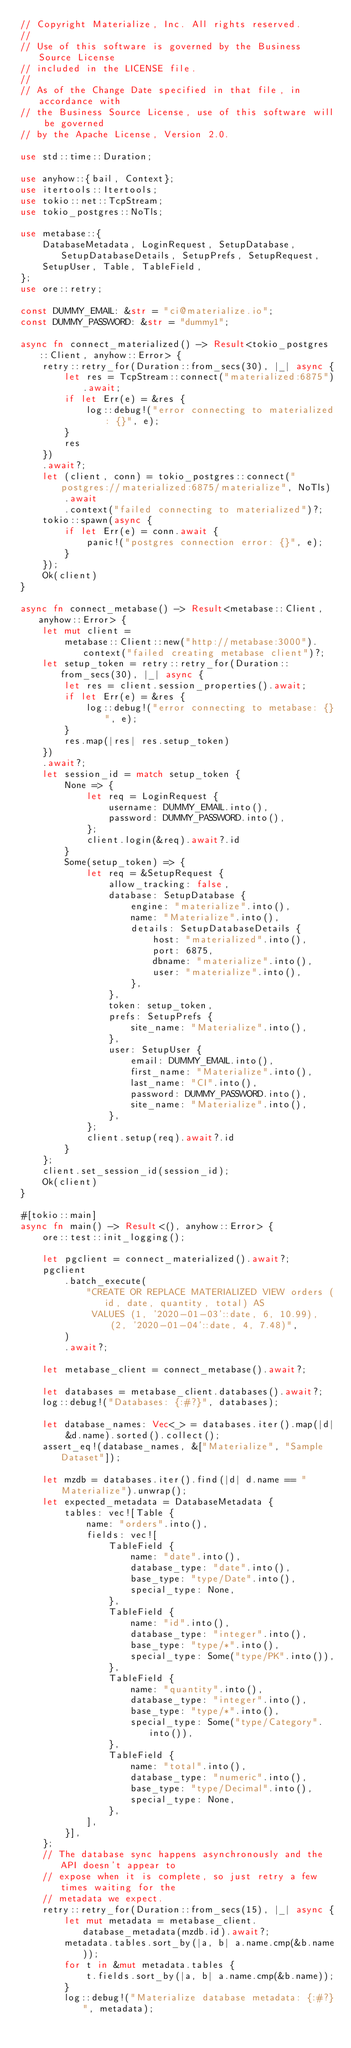<code> <loc_0><loc_0><loc_500><loc_500><_Rust_>// Copyright Materialize, Inc. All rights reserved.
//
// Use of this software is governed by the Business Source License
// included in the LICENSE file.
//
// As of the Change Date specified in that file, in accordance with
// the Business Source License, use of this software will be governed
// by the Apache License, Version 2.0.

use std::time::Duration;

use anyhow::{bail, Context};
use itertools::Itertools;
use tokio::net::TcpStream;
use tokio_postgres::NoTls;

use metabase::{
    DatabaseMetadata, LoginRequest, SetupDatabase, SetupDatabaseDetails, SetupPrefs, SetupRequest,
    SetupUser, Table, TableField,
};
use ore::retry;

const DUMMY_EMAIL: &str = "ci@materialize.io";
const DUMMY_PASSWORD: &str = "dummy1";

async fn connect_materialized() -> Result<tokio_postgres::Client, anyhow::Error> {
    retry::retry_for(Duration::from_secs(30), |_| async {
        let res = TcpStream::connect("materialized:6875").await;
        if let Err(e) = &res {
            log::debug!("error connecting to materialized: {}", e);
        }
        res
    })
    .await?;
    let (client, conn) = tokio_postgres::connect("postgres://materialized:6875/materialize", NoTls)
        .await
        .context("failed connecting to materialized")?;
    tokio::spawn(async {
        if let Err(e) = conn.await {
            panic!("postgres connection error: {}", e);
        }
    });
    Ok(client)
}

async fn connect_metabase() -> Result<metabase::Client, anyhow::Error> {
    let mut client =
        metabase::Client::new("http://metabase:3000").context("failed creating metabase client")?;
    let setup_token = retry::retry_for(Duration::from_secs(30), |_| async {
        let res = client.session_properties().await;
        if let Err(e) = &res {
            log::debug!("error connecting to metabase: {}", e);
        }
        res.map(|res| res.setup_token)
    })
    .await?;
    let session_id = match setup_token {
        None => {
            let req = LoginRequest {
                username: DUMMY_EMAIL.into(),
                password: DUMMY_PASSWORD.into(),
            };
            client.login(&req).await?.id
        }
        Some(setup_token) => {
            let req = &SetupRequest {
                allow_tracking: false,
                database: SetupDatabase {
                    engine: "materialize".into(),
                    name: "Materialize".into(),
                    details: SetupDatabaseDetails {
                        host: "materialized".into(),
                        port: 6875,
                        dbname: "materialize".into(),
                        user: "materialize".into(),
                    },
                },
                token: setup_token,
                prefs: SetupPrefs {
                    site_name: "Materialize".into(),
                },
                user: SetupUser {
                    email: DUMMY_EMAIL.into(),
                    first_name: "Materialize".into(),
                    last_name: "CI".into(),
                    password: DUMMY_PASSWORD.into(),
                    site_name: "Materialize".into(),
                },
            };
            client.setup(req).await?.id
        }
    };
    client.set_session_id(session_id);
    Ok(client)
}

#[tokio::main]
async fn main() -> Result<(), anyhow::Error> {
    ore::test::init_logging();

    let pgclient = connect_materialized().await?;
    pgclient
        .batch_execute(
            "CREATE OR REPLACE MATERIALIZED VIEW orders (id, date, quantity, total) AS
             VALUES (1, '2020-01-03'::date, 6, 10.99), (2, '2020-01-04'::date, 4, 7.48)",
        )
        .await?;

    let metabase_client = connect_metabase().await?;

    let databases = metabase_client.databases().await?;
    log::debug!("Databases: {:#?}", databases);

    let database_names: Vec<_> = databases.iter().map(|d| &d.name).sorted().collect();
    assert_eq!(database_names, &["Materialize", "Sample Dataset"]);

    let mzdb = databases.iter().find(|d| d.name == "Materialize").unwrap();
    let expected_metadata = DatabaseMetadata {
        tables: vec![Table {
            name: "orders".into(),
            fields: vec![
                TableField {
                    name: "date".into(),
                    database_type: "date".into(),
                    base_type: "type/Date".into(),
                    special_type: None,
                },
                TableField {
                    name: "id".into(),
                    database_type: "integer".into(),
                    base_type: "type/*".into(),
                    special_type: Some("type/PK".into()),
                },
                TableField {
                    name: "quantity".into(),
                    database_type: "integer".into(),
                    base_type: "type/*".into(),
                    special_type: Some("type/Category".into()),
                },
                TableField {
                    name: "total".into(),
                    database_type: "numeric".into(),
                    base_type: "type/Decimal".into(),
                    special_type: None,
                },
            ],
        }],
    };
    // The database sync happens asynchronously and the API doesn't appear to
    // expose when it is complete, so just retry a few times waiting for the
    // metadata we expect.
    retry::retry_for(Duration::from_secs(15), |_| async {
        let mut metadata = metabase_client.database_metadata(mzdb.id).await?;
        metadata.tables.sort_by(|a, b| a.name.cmp(&b.name));
        for t in &mut metadata.tables {
            t.fields.sort_by(|a, b| a.name.cmp(&b.name));
        }
        log::debug!("Materialize database metadata: {:#?}", metadata);</code> 